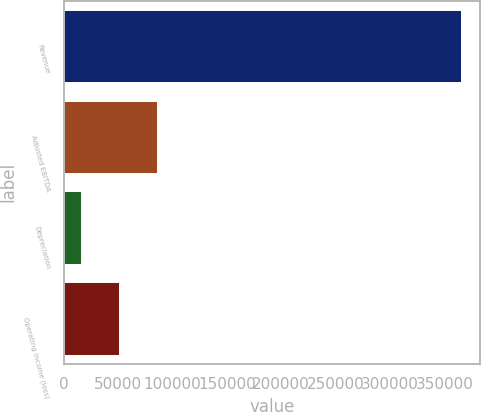<chart> <loc_0><loc_0><loc_500><loc_500><bar_chart><fcel>Revenue<fcel>Adjusted EBITDA<fcel>Depreciation<fcel>Operating income (loss)<nl><fcel>364923<fcel>85622.2<fcel>15797<fcel>50709.6<nl></chart> 